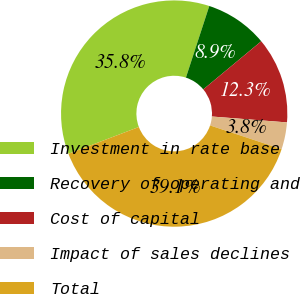<chart> <loc_0><loc_0><loc_500><loc_500><pie_chart><fcel>Investment in rate base<fcel>Recovery of operating and<fcel>Cost of capital<fcel>Impact of sales declines<fcel>Total<nl><fcel>35.81%<fcel>8.95%<fcel>12.28%<fcel>3.84%<fcel>39.13%<nl></chart> 